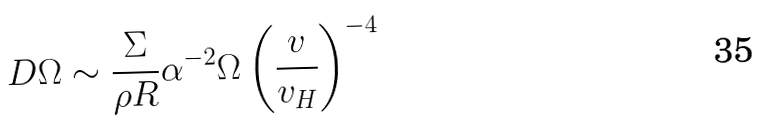Convert formula to latex. <formula><loc_0><loc_0><loc_500><loc_500>D \Omega \sim \frac { \Sigma } { \rho R } \alpha ^ { - 2 } \Omega \left ( \frac { v } { v _ { H } } \right ) ^ { - 4 }</formula> 